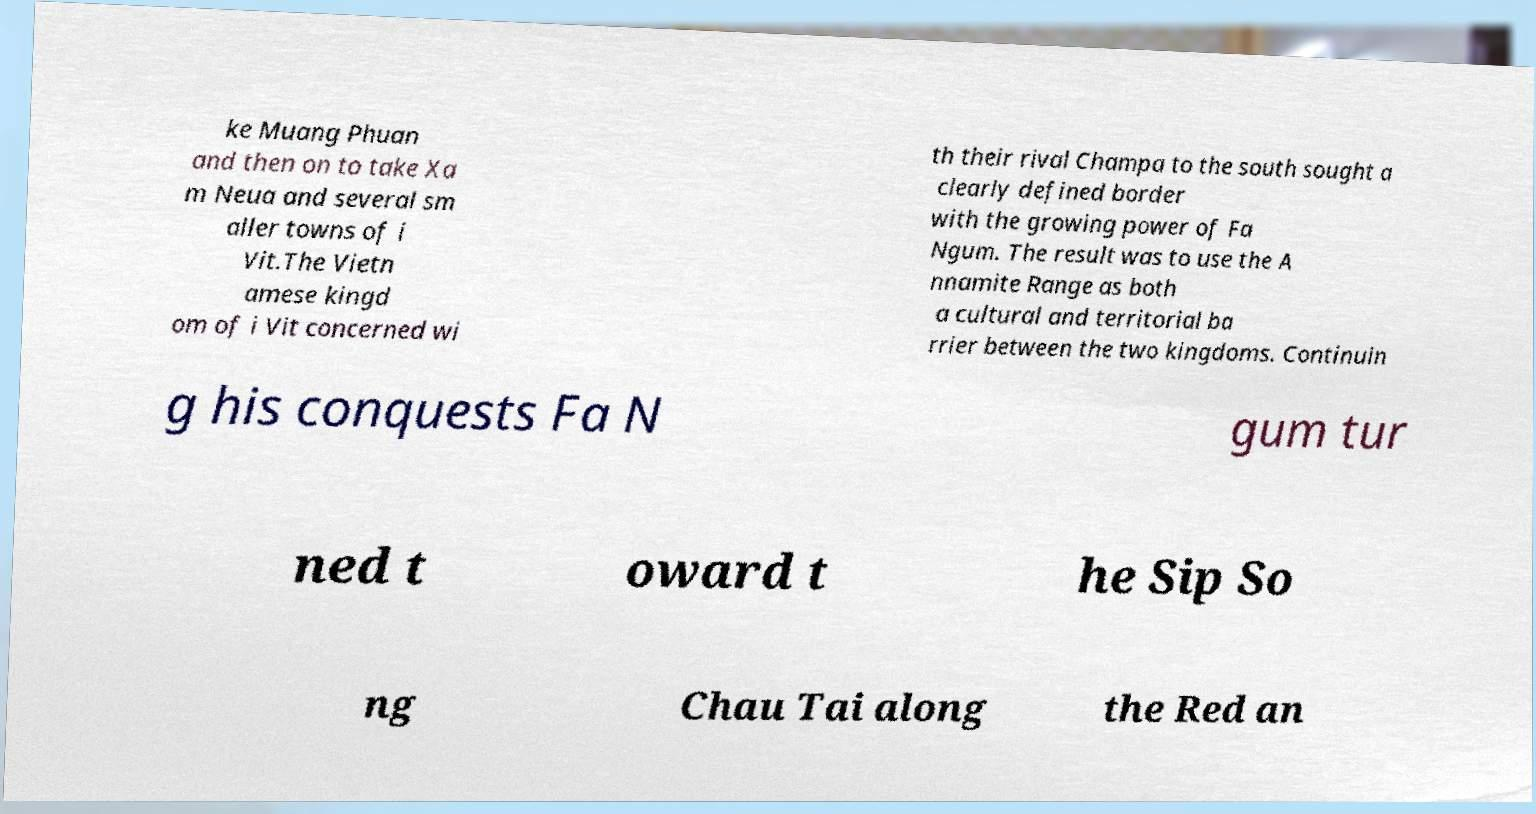I need the written content from this picture converted into text. Can you do that? ke Muang Phuan and then on to take Xa m Neua and several sm aller towns of i Vit.The Vietn amese kingd om of i Vit concerned wi th their rival Champa to the south sought a clearly defined border with the growing power of Fa Ngum. The result was to use the A nnamite Range as both a cultural and territorial ba rrier between the two kingdoms. Continuin g his conquests Fa N gum tur ned t oward t he Sip So ng Chau Tai along the Red an 